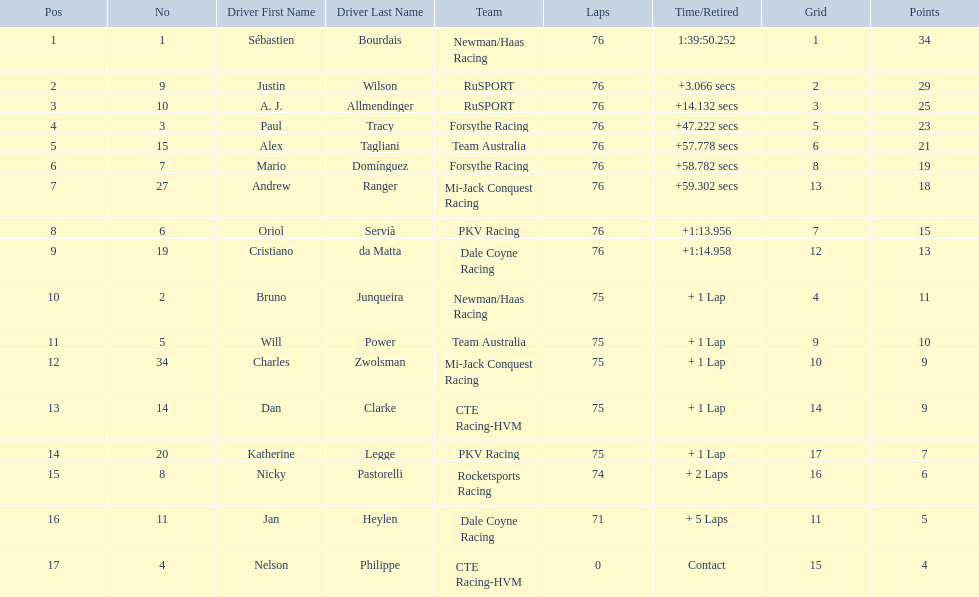How many points did charles zwolsman acquire? 9. Who else got 9 points? Dan Clarke. 